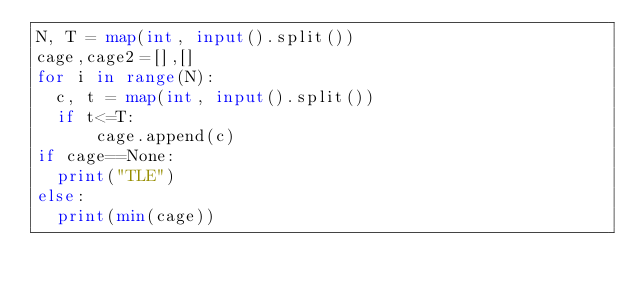Convert code to text. <code><loc_0><loc_0><loc_500><loc_500><_Python_>N, T = map(int, input().split())
cage,cage2=[],[]
for i in range(N):
  c, t = map(int, input().split())
  if t<=T:
      cage.append(c)
if cage==None:
  print("TLE")
else:
  print(min(cage))</code> 